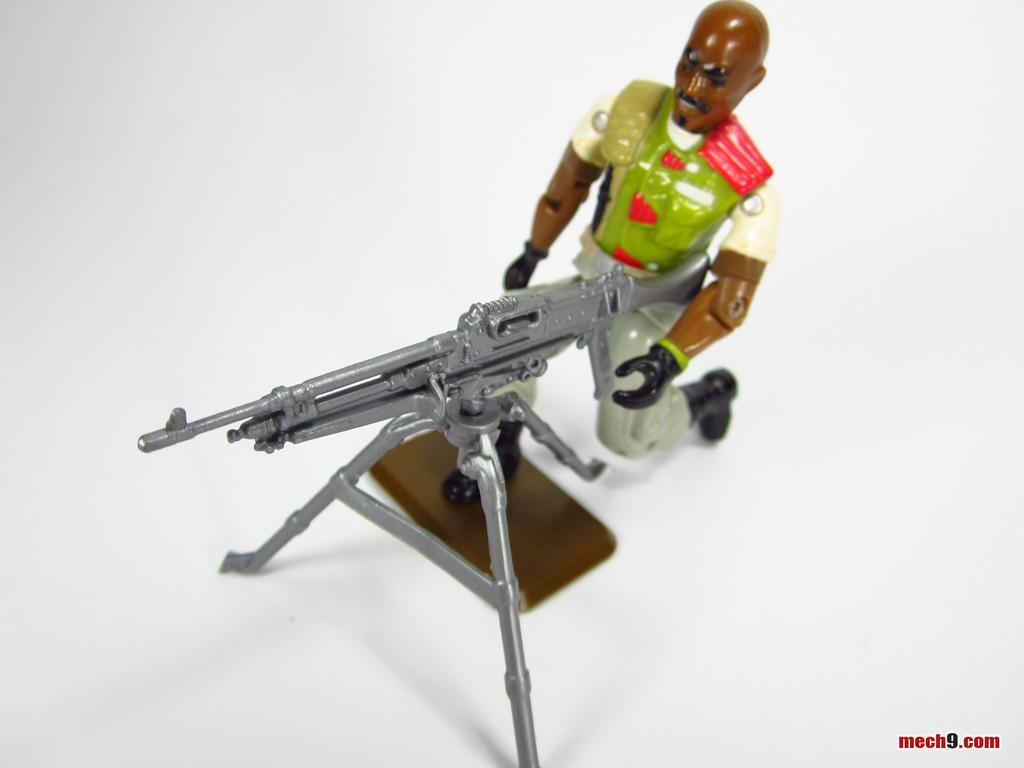What type of object is in the image? There is a toy person in the image. What is the toy person holding? The toy person is holding a rifle. How is the rifle positioned in the image? The rifle is on a stand. Is there any additional information about the image itself? Yes, there is a watermark on the image. Can you tell me how many zippers are on the toy person's outfit in the image? There is no mention of zippers on the toy person's outfit in the image, so it cannot be determined from the provided facts. 